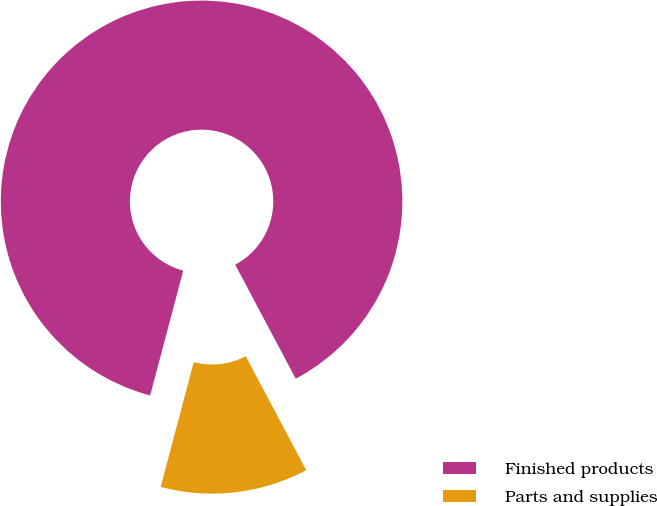Convert chart. <chart><loc_0><loc_0><loc_500><loc_500><pie_chart><fcel>Finished products<fcel>Parts and supplies<nl><fcel>88.11%<fcel>11.89%<nl></chart> 